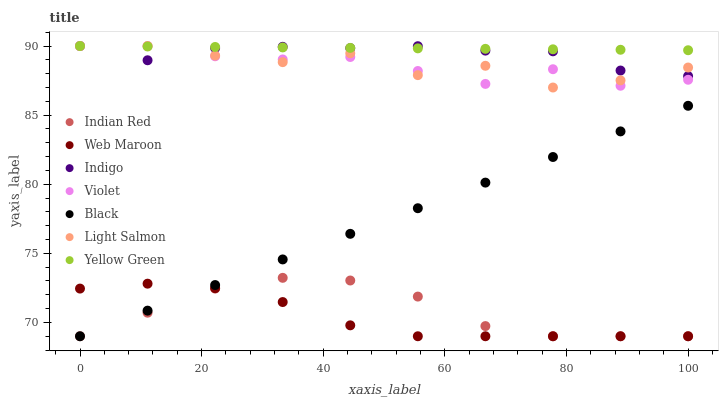Does Web Maroon have the minimum area under the curve?
Answer yes or no. Yes. Does Yellow Green have the maximum area under the curve?
Answer yes or no. Yes. Does Indigo have the minimum area under the curve?
Answer yes or no. No. Does Indigo have the maximum area under the curve?
Answer yes or no. No. Is Yellow Green the smoothest?
Answer yes or no. Yes. Is Light Salmon the roughest?
Answer yes or no. Yes. Is Indigo the smoothest?
Answer yes or no. No. Is Indigo the roughest?
Answer yes or no. No. Does Web Maroon have the lowest value?
Answer yes or no. Yes. Does Indigo have the lowest value?
Answer yes or no. No. Does Violet have the highest value?
Answer yes or no. Yes. Does Web Maroon have the highest value?
Answer yes or no. No. Is Web Maroon less than Yellow Green?
Answer yes or no. Yes. Is Yellow Green greater than Black?
Answer yes or no. Yes. Does Light Salmon intersect Indigo?
Answer yes or no. Yes. Is Light Salmon less than Indigo?
Answer yes or no. No. Is Light Salmon greater than Indigo?
Answer yes or no. No. Does Web Maroon intersect Yellow Green?
Answer yes or no. No. 